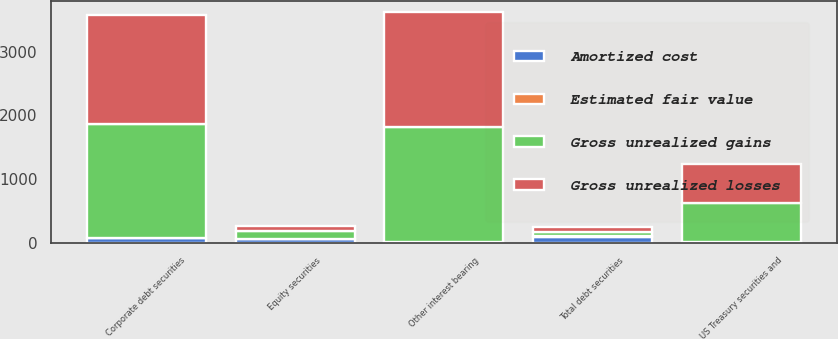Convert chart. <chart><loc_0><loc_0><loc_500><loc_500><stacked_bar_chart><ecel><fcel>Corporate debt securities<fcel>Other interest bearing<fcel>Total debt securities<fcel>Equity securities<fcel>US Treasury securities and<nl><fcel>Gross unrealized losses<fcel>1708.7<fcel>1806.8<fcel>73.1<fcel>68.9<fcel>601.3<nl><fcel>Amortized cost<fcel>77.3<fcel>1<fcel>96<fcel>60.6<fcel>12.1<nl><fcel>Estimated fair value<fcel>0.2<fcel>1.4<fcel>1.6<fcel>2.7<fcel>0.2<nl><fcel>Gross unrealized gains<fcel>1785.8<fcel>1806.4<fcel>73.1<fcel>126.8<fcel>613.2<nl></chart> 